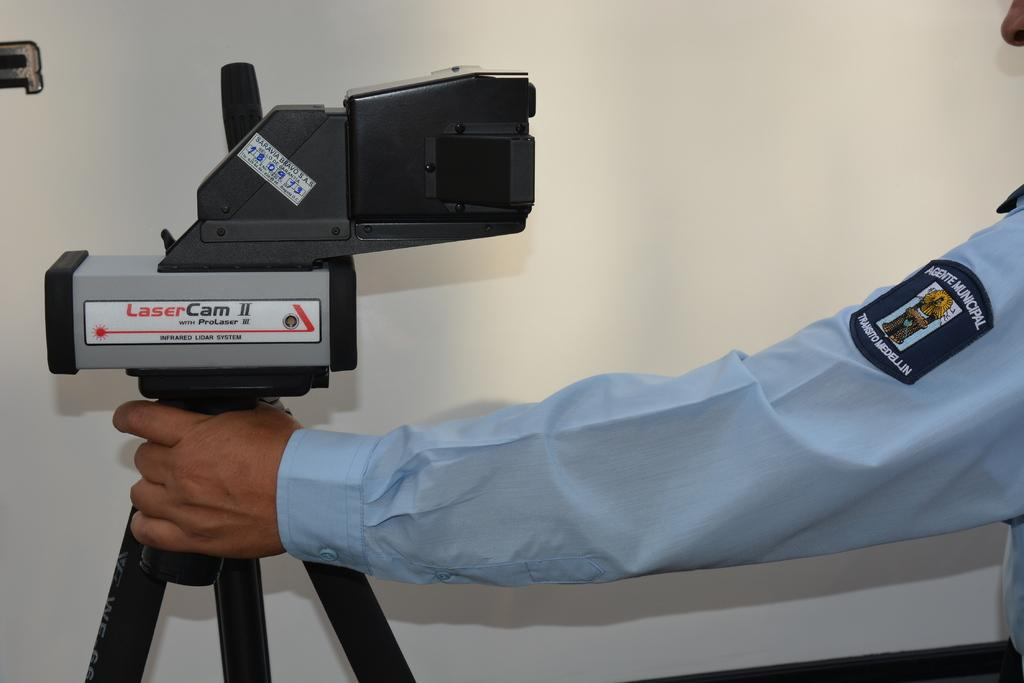What can be seen in the image that belongs to a person? There is a hand of a person in the image. What device is present on the left side of the image? There is a laser cam on the left side of the image. Is there any support for the laser cam in the image? Yes, there is a stand associated with the laser cam. What can be seen in the background of the image? There is a wall in the background of the image. What type of wine is being served at the feast in the image? There is no feast or wine present in the image; it features a hand, a laser cam, and a stand. How many planes are visible in the image? There are no planes visible in the image. 